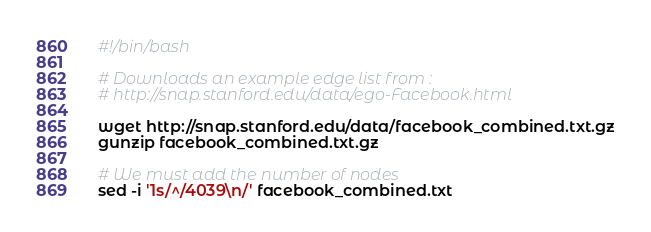Convert code to text. <code><loc_0><loc_0><loc_500><loc_500><_Bash_>#!/bin/bash

# Downloads an example edge list from :
# http://snap.stanford.edu/data/ego-Facebook.html

wget http://snap.stanford.edu/data/facebook_combined.txt.gz
gunzip facebook_combined.txt.gz

# We must add the number of nodes
sed -i '1s/^/4039\n/' facebook_combined.txt
</code> 